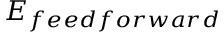Convert formula to latex. <formula><loc_0><loc_0><loc_500><loc_500>E _ { f e e d f o r w a r d }</formula> 